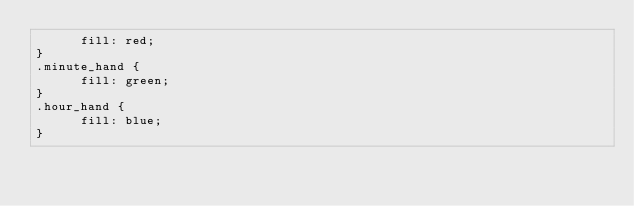Convert code to text. <code><loc_0><loc_0><loc_500><loc_500><_CSS_>      fill: red;
}
.minute_hand {
      fill: green;
}
.hour_hand {
      fill: blue;
}
</code> 